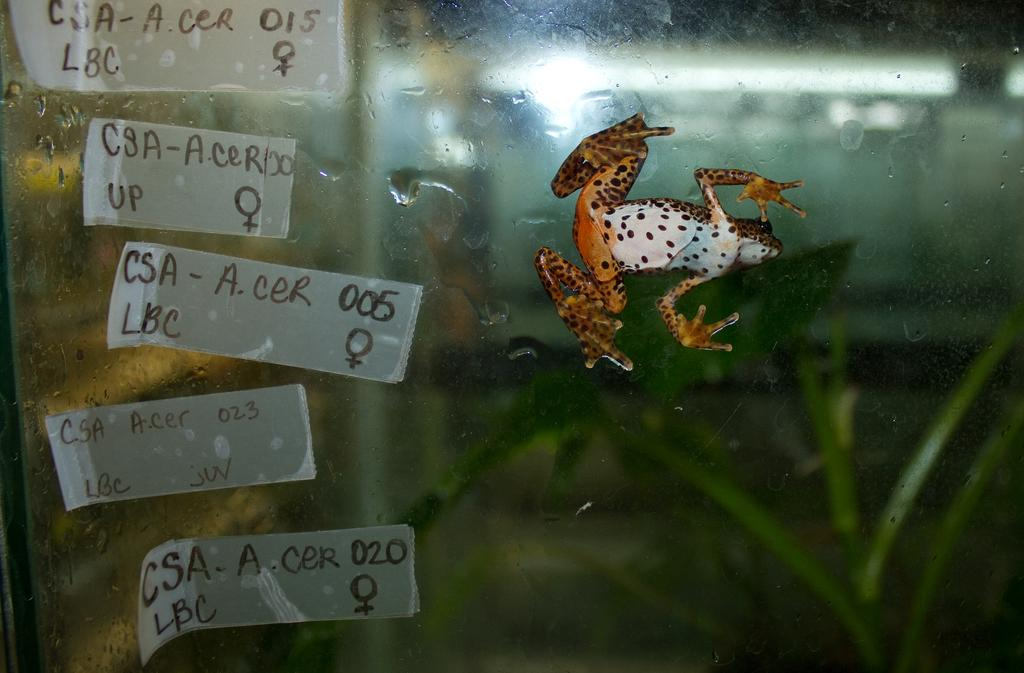What object in the image appears to be wet? There is a wet glass in the image. What type of animal can be seen in the image? A frog is crawling on the grass in the image. What is located on the left side of the glass in the image? There are small papers with notes on the left side of the glass in the image. What type of bed is visible in the image? There is no bed present in the image. What is the secretary doing in the image? There is no secretary present in the image. 